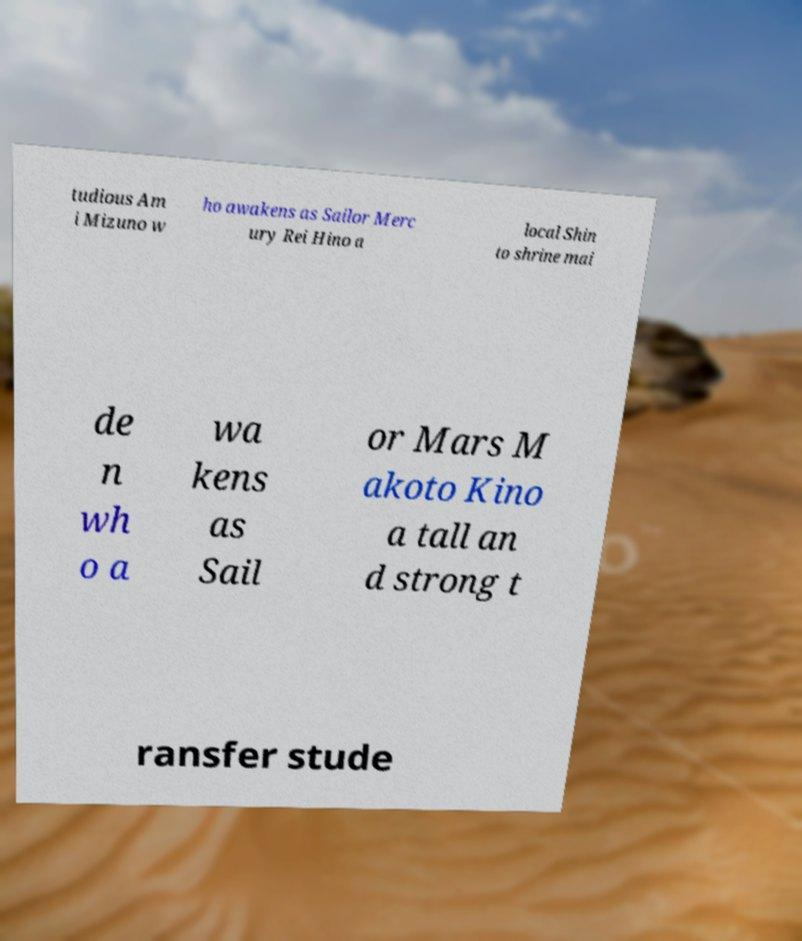Please read and relay the text visible in this image. What does it say? tudious Am i Mizuno w ho awakens as Sailor Merc ury Rei Hino a local Shin to shrine mai de n wh o a wa kens as Sail or Mars M akoto Kino a tall an d strong t ransfer stude 